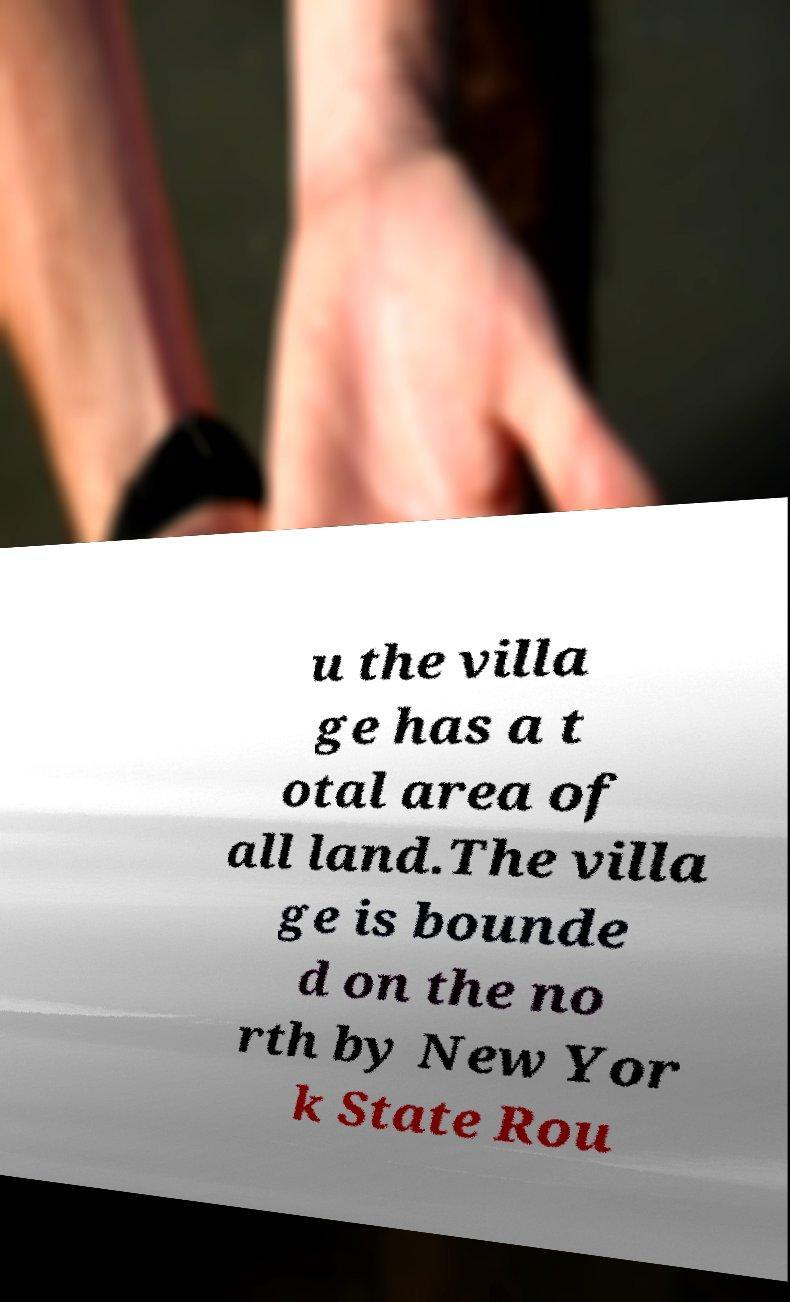Can you accurately transcribe the text from the provided image for me? u the villa ge has a t otal area of all land.The villa ge is bounde d on the no rth by New Yor k State Rou 